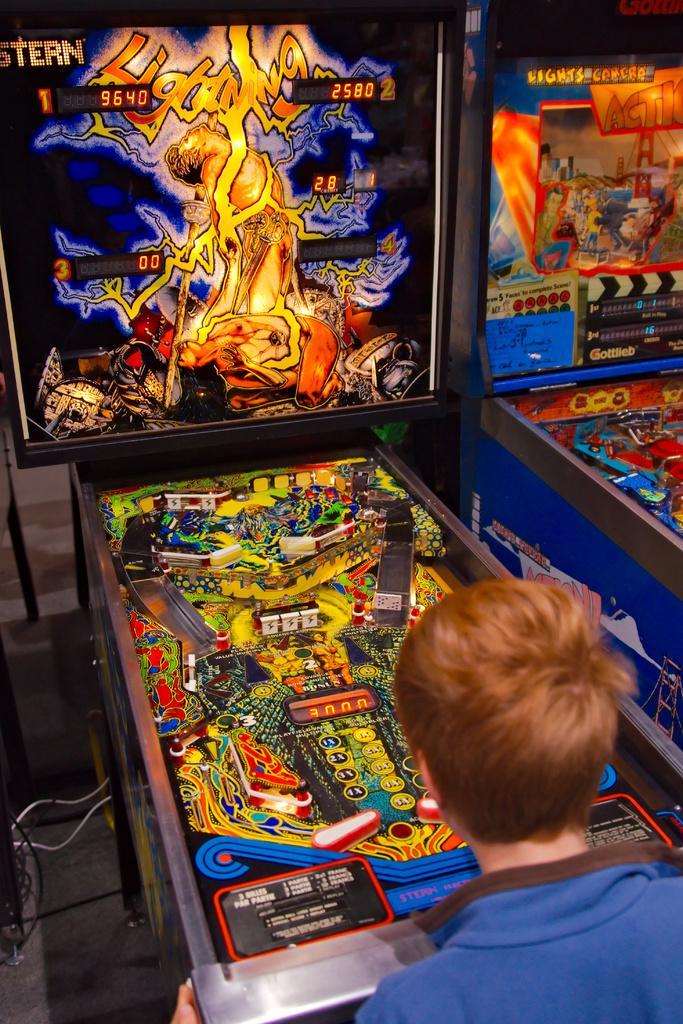Who is the main subject in the image? There is a boy in the image. What is the boy doing in the image? The boy is standing and playing a game. What is the boy interacting with while playing the game? There is a screen with a game in front of the boy. What type of steel is the boy using to play the game in the image? There is no steel present in the image; the boy is playing a game on a screen. 